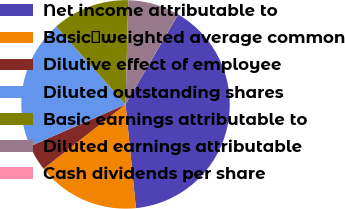Convert chart to OTSL. <chart><loc_0><loc_0><loc_500><loc_500><pie_chart><fcel>Net income attributable to<fcel>Basicweighted average common<fcel>Dilutive effect of employee<fcel>Diluted outstanding shares<fcel>Basic earnings attributable to<fcel>Diluted earnings attributable<fcel>Cash dividends per share<nl><fcel>39.98%<fcel>16.0%<fcel>4.01%<fcel>20.0%<fcel>12.0%<fcel>8.0%<fcel>0.01%<nl></chart> 